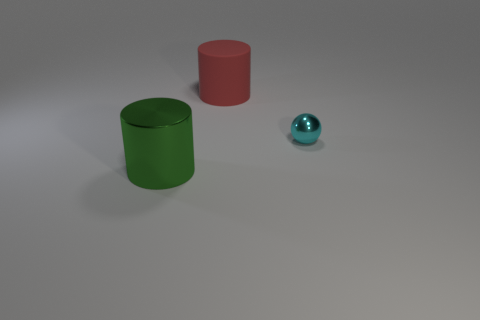Is there any other thing that is the same size as the cyan metallic ball?
Your answer should be very brief. No. What number of objects are either cylinders right of the green shiny cylinder or large cylinders right of the large shiny thing?
Your answer should be compact. 1. What shape is the small thing?
Your answer should be compact. Sphere. How many other things are made of the same material as the red object?
Your answer should be very brief. 0. The red matte object that is the same shape as the large metal thing is what size?
Make the answer very short. Large. There is a thing that is in front of the sphere behind the object that is on the left side of the big red matte cylinder; what is it made of?
Offer a terse response. Metal. Are there any big metallic cylinders?
Offer a very short reply. Yes. What color is the large metallic cylinder?
Offer a terse response. Green. Is there any other thing that has the same shape as the tiny cyan shiny thing?
Keep it short and to the point. No. What is the color of the rubber thing that is the same shape as the green metal thing?
Ensure brevity in your answer.  Red. 